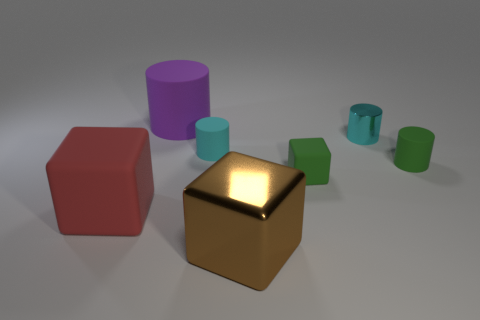There is a cyan cylinder that is right of the brown object; what number of tiny green cylinders are behind it?
Offer a terse response. 0. Is there any other thing that has the same color as the metallic cylinder?
Offer a very short reply. Yes. There is a large thing that is made of the same material as the big cylinder; what is its shape?
Ensure brevity in your answer.  Cube. Is the material of the small cyan cylinder behind the cyan rubber cylinder the same as the object that is left of the big matte cylinder?
Make the answer very short. No. How many objects are red rubber blocks or metal things that are in front of the green matte cylinder?
Provide a succinct answer. 2. What shape is the tiny object that is the same color as the small block?
Offer a terse response. Cylinder. What is the material of the brown cube?
Provide a short and direct response. Metal. Is the tiny cube made of the same material as the big purple cylinder?
Offer a very short reply. Yes. What number of metallic objects are either green cylinders or tiny blue cubes?
Your answer should be very brief. 0. The large rubber thing that is behind the red block has what shape?
Your answer should be compact. Cylinder. 